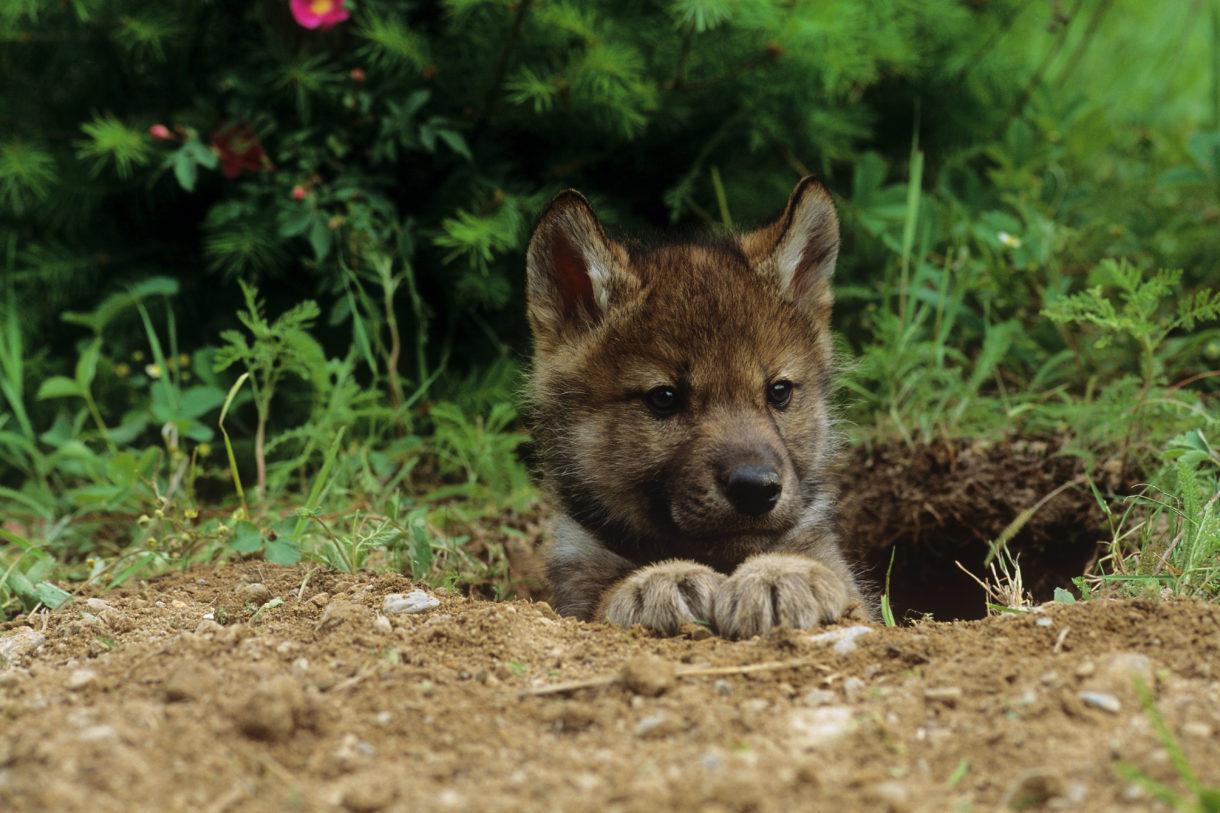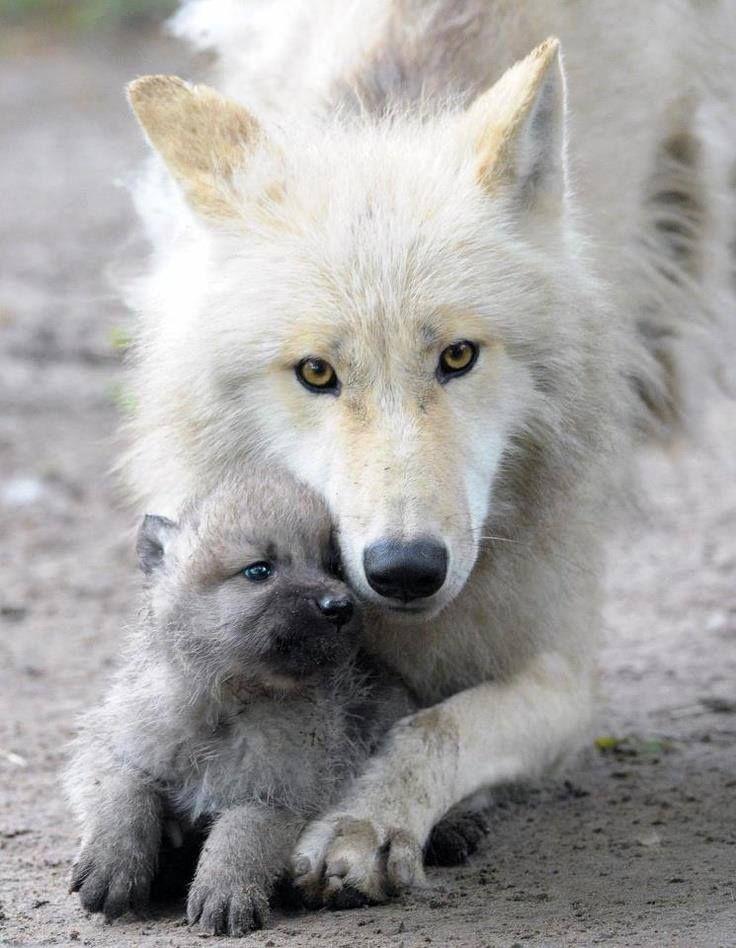The first image is the image on the left, the second image is the image on the right. Examine the images to the left and right. Is the description "The left image features a pair of wolf pups posed with one head on top of the other's head, and the right image includes an adult wolf with at least one pup." accurate? Answer yes or no. No. The first image is the image on the left, the second image is the image on the right. Assess this claim about the two images: "The left image contains two baby wolves laying down together.". Correct or not? Answer yes or no. No. 